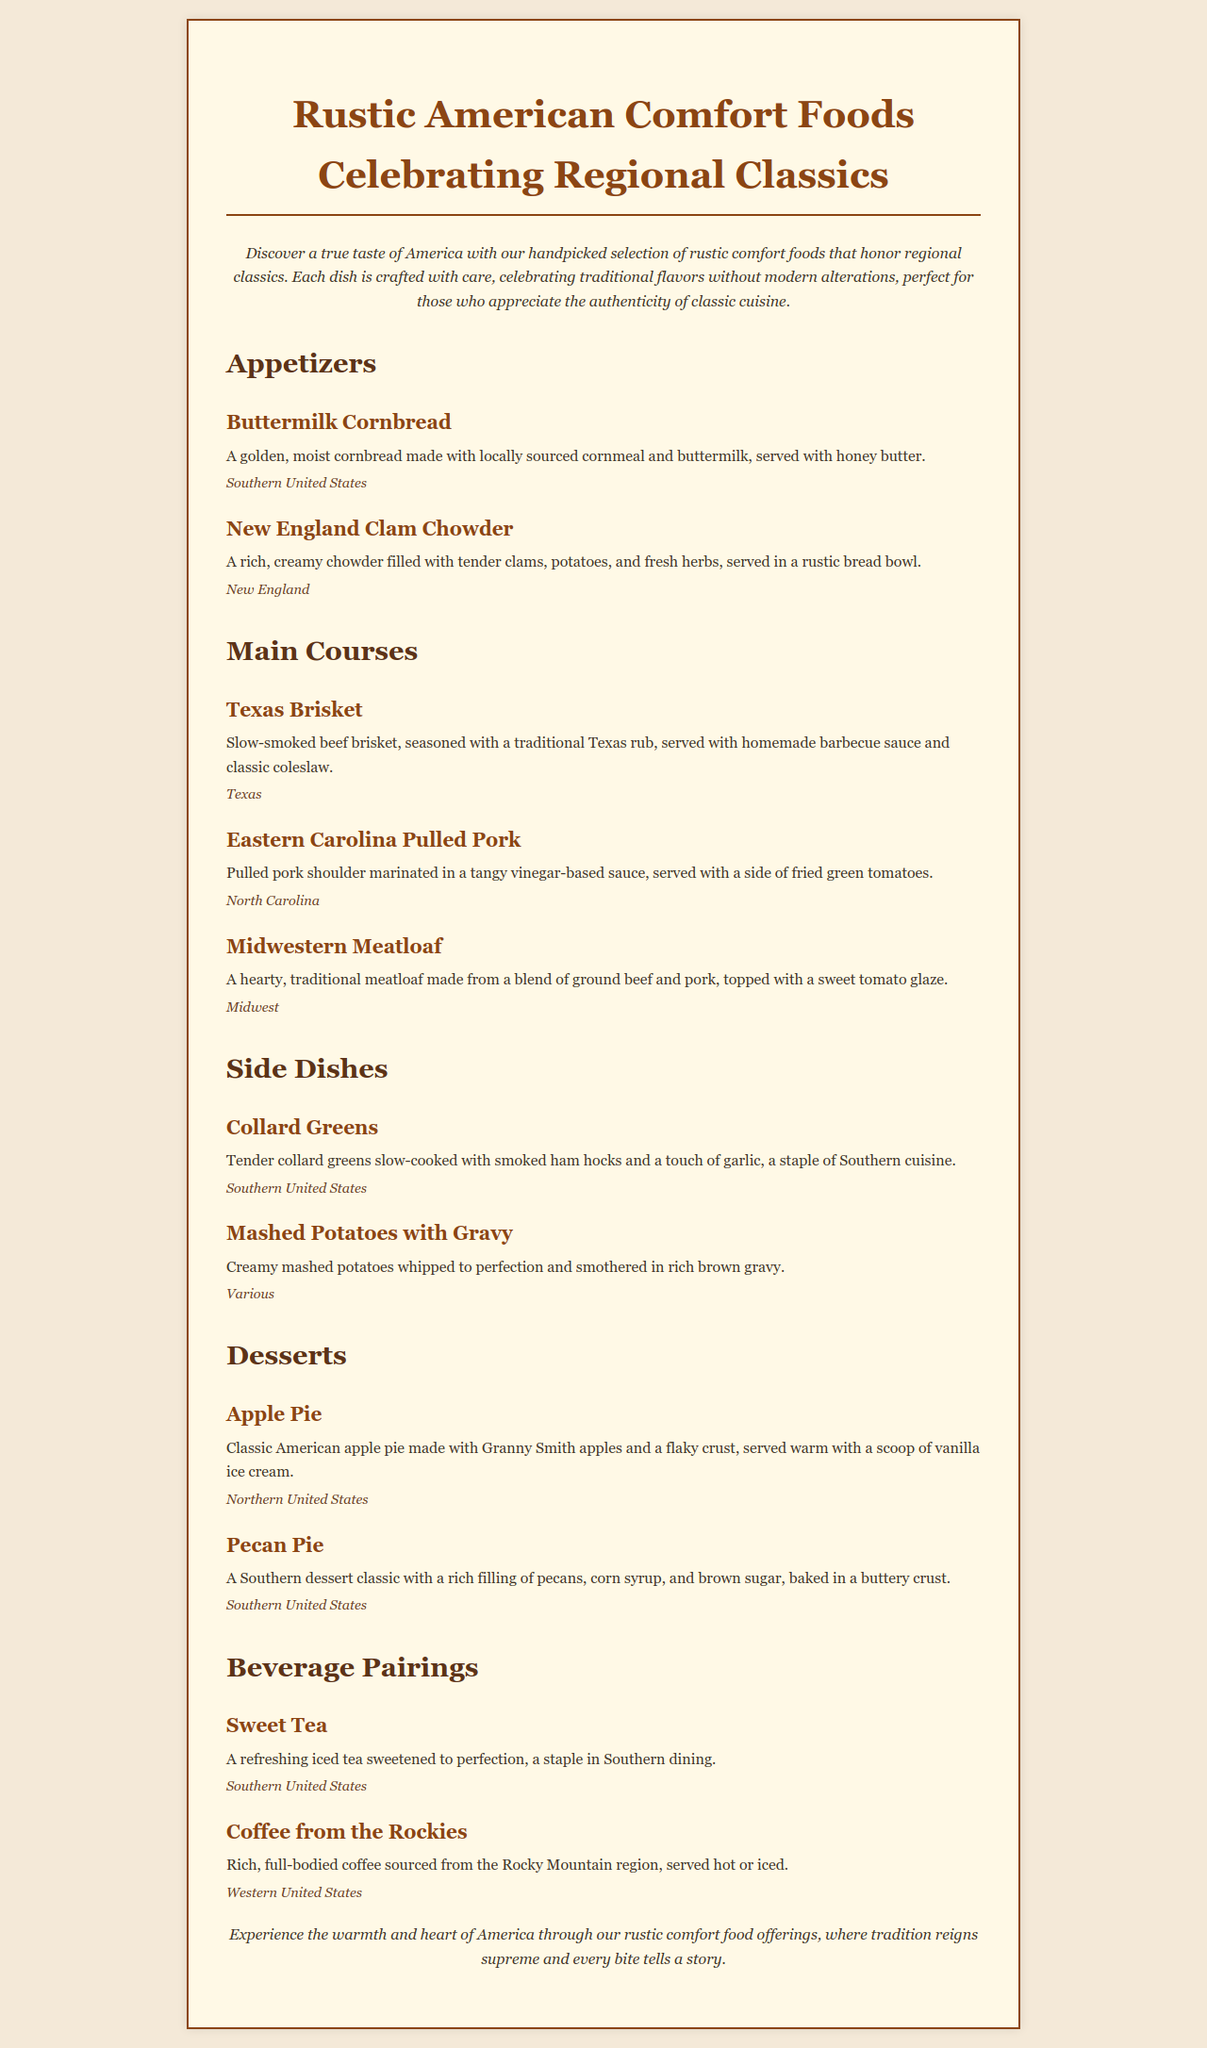What is the first appetizer listed? The first appetizer listed in the menu is Buttermilk Cornbread.
Answer: Buttermilk Cornbread How many main courses are featured in the menu? There are three main courses listed in the menu: Texas Brisket, Eastern Carolina Pulled Pork, and Midwestern Meatloaf.
Answer: Three What is the region associated with the New England Clam Chowder? The region associated with the New England Clam Chowder is New England.
Answer: New England Which dessert is made with Granny Smith apples? The dessert made with Granny Smith apples is Apple Pie.
Answer: Apple Pie What beverage is a staple in Southern dining? The beverage that is a staple in Southern dining is Sweet Tea.
Answer: Sweet Tea Which main course includes a vinegar-based sauce? The main course that includes a vinegar-based sauce is Eastern Carolina Pulled Pork.
Answer: Eastern Carolina Pulled Pork What type of coffee is featured from the beverage section? The type of coffee featured from the beverage section is Coffee from the Rockies.
Answer: Coffee from the Rockies What is the conclusion of the menu about? The conclusion of the menu emphasizes the warmth and heart of America through rustic comfort food offerings.
Answer: Warmth and heart of America 